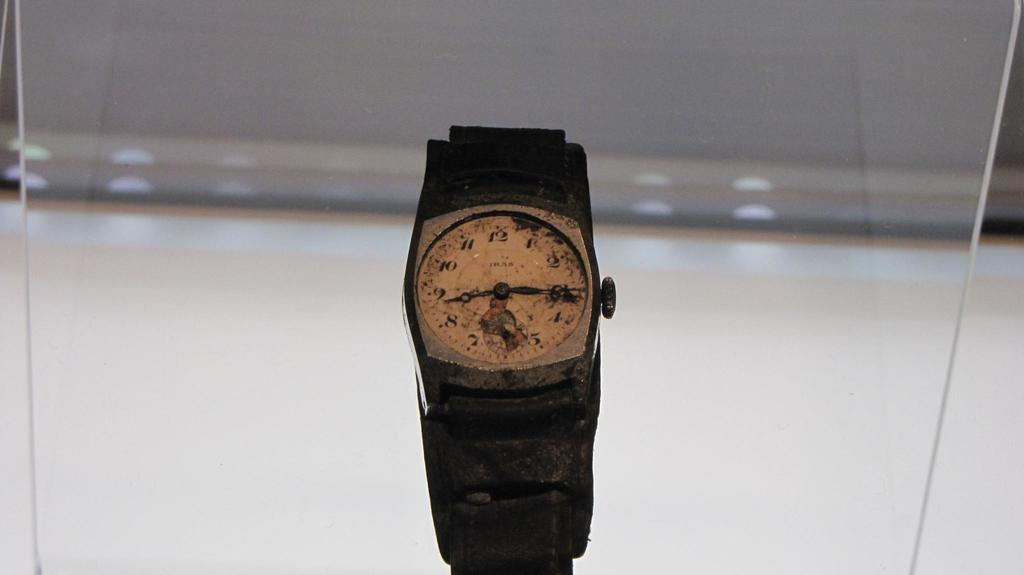<image>
Give a short and clear explanation of the subsequent image. A watch on a glass display with the numbers on the face displayed in regular Arabic numerals. 